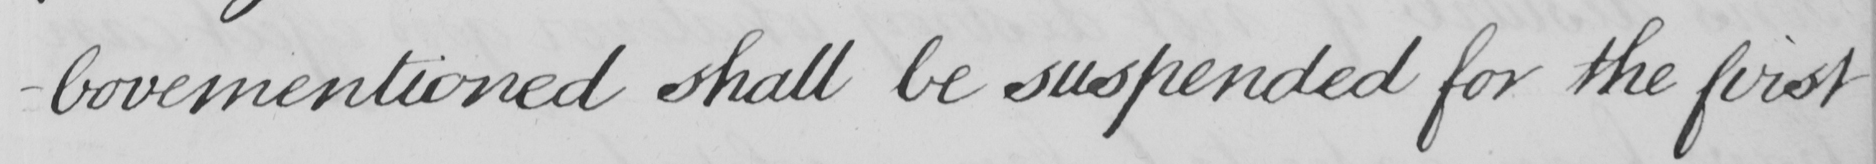What is written in this line of handwriting? -bovementioned shall be suspended for the first 